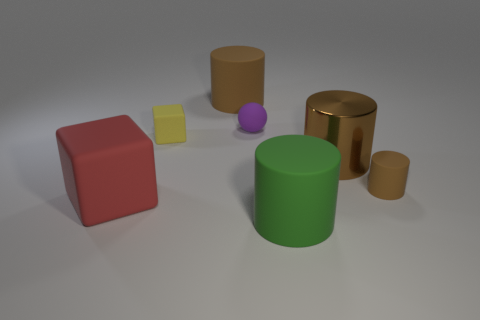Subtract all brown cylinders. How many were subtracted if there are1brown cylinders left? 2 Subtract all yellow cubes. How many brown cylinders are left? 3 Subtract all large brown metallic cylinders. How many cylinders are left? 3 Add 3 large cylinders. How many objects exist? 10 Subtract all green cylinders. How many cylinders are left? 3 Subtract all spheres. How many objects are left? 6 Subtract all blue cylinders. Subtract all gray cubes. How many cylinders are left? 4 Add 6 large green things. How many large green things are left? 7 Add 6 green blocks. How many green blocks exist? 6 Subtract 0 gray balls. How many objects are left? 7 